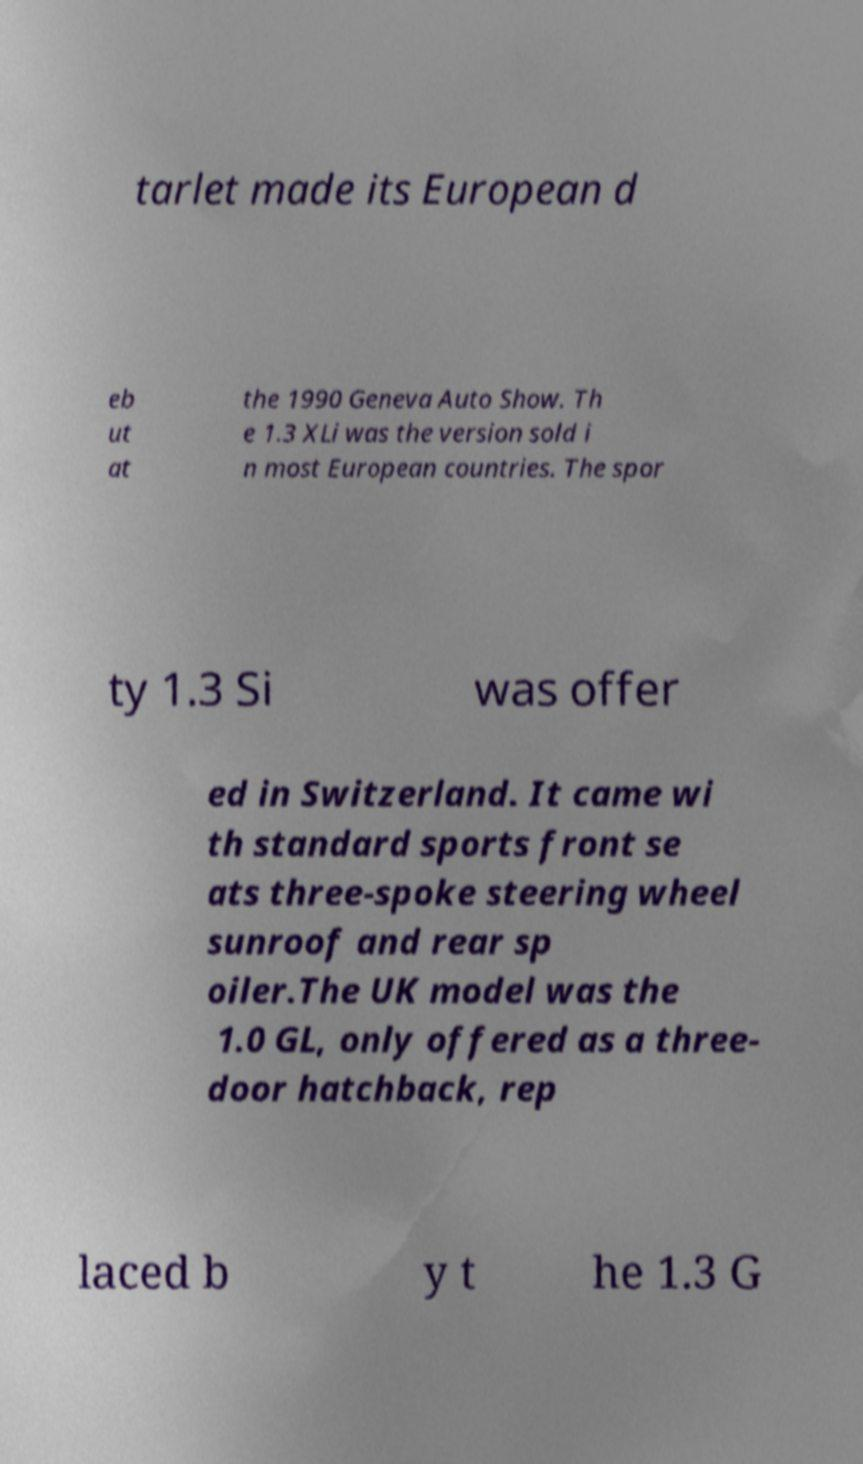What messages or text are displayed in this image? I need them in a readable, typed format. tarlet made its European d eb ut at the 1990 Geneva Auto Show. Th e 1.3 XLi was the version sold i n most European countries. The spor ty 1.3 Si was offer ed in Switzerland. It came wi th standard sports front se ats three-spoke steering wheel sunroof and rear sp oiler.The UK model was the 1.0 GL, only offered as a three- door hatchback, rep laced b y t he 1.3 G 